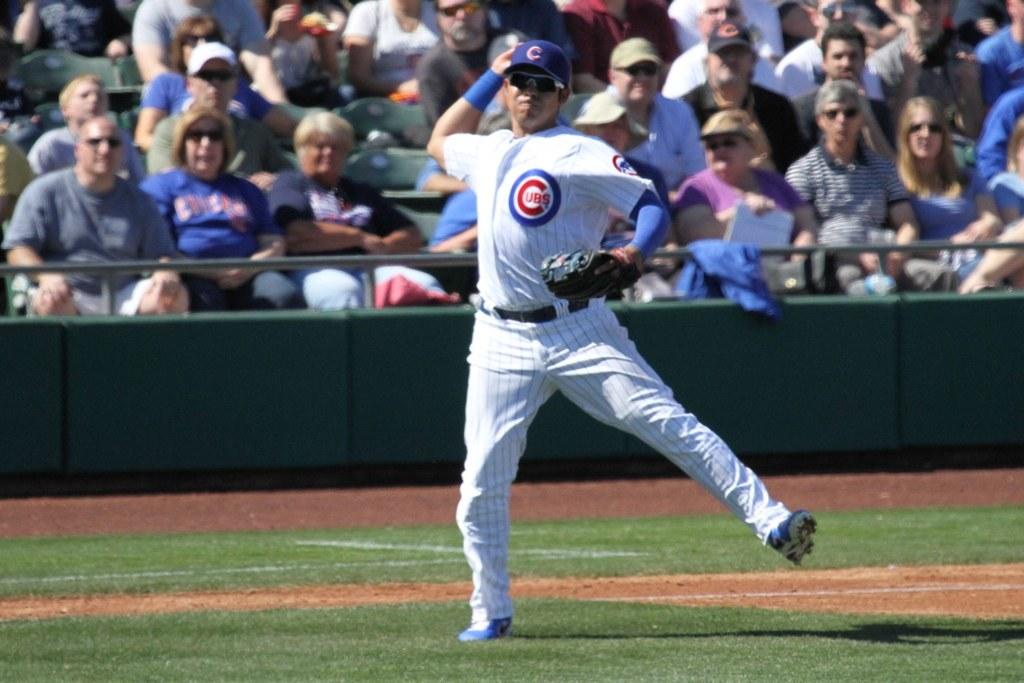Is cubs a professional baseball team?
Your answer should be compact. Answering does not require reading text in the image. 